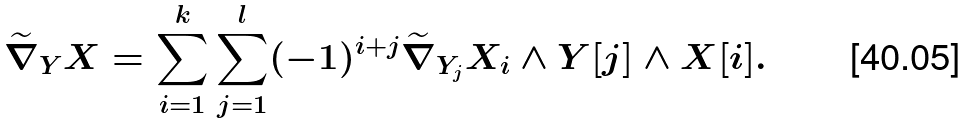Convert formula to latex. <formula><loc_0><loc_0><loc_500><loc_500>\widetilde { \nabla } _ { Y } X = \sum _ { i = 1 } ^ { k } \sum _ { j = 1 } ^ { l } ( - 1 ) ^ { i + j } \widetilde { \nabla } _ { Y _ { j } } X _ { i } \wedge Y [ j ] \wedge X [ i ] .</formula> 